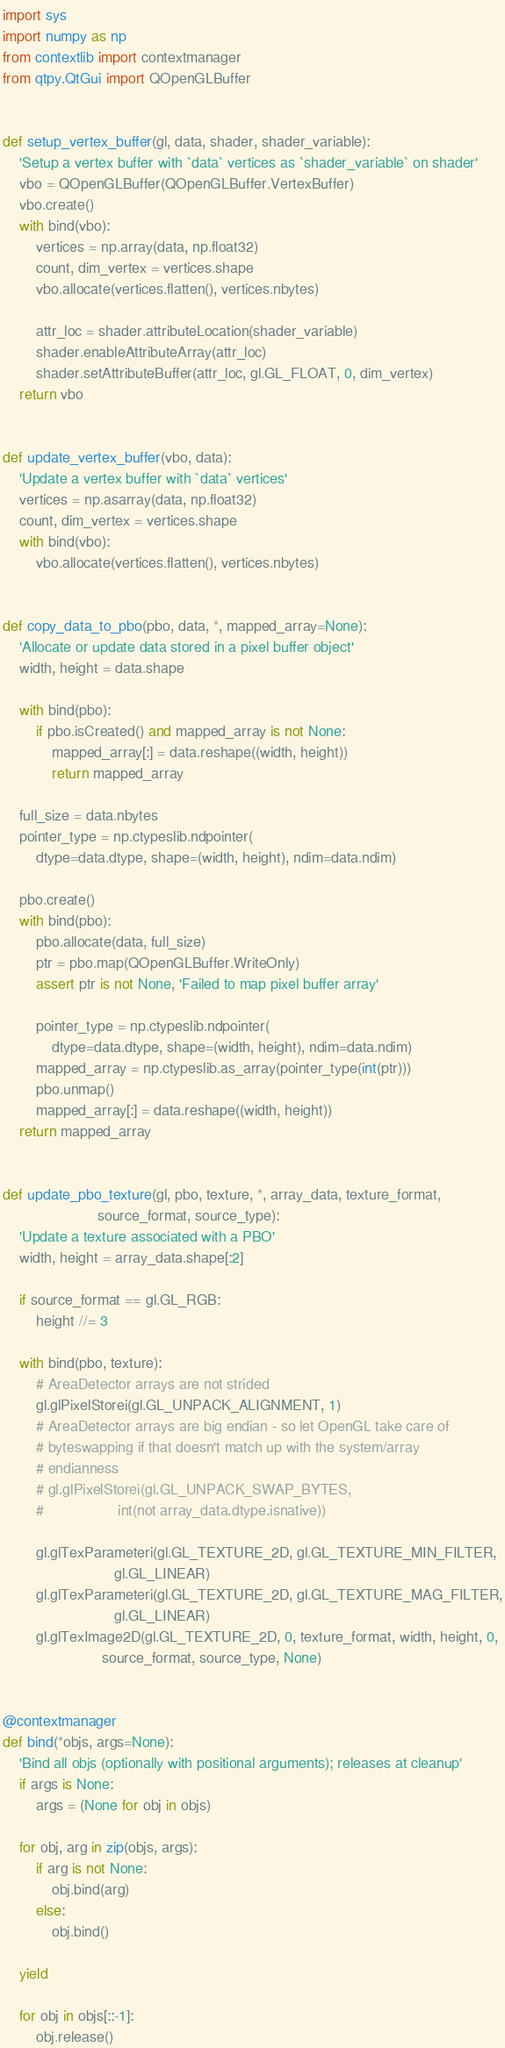<code> <loc_0><loc_0><loc_500><loc_500><_Python_>import sys
import numpy as np
from contextlib import contextmanager
from qtpy.QtGui import QOpenGLBuffer


def setup_vertex_buffer(gl, data, shader, shader_variable):
    'Setup a vertex buffer with `data` vertices as `shader_variable` on shader'
    vbo = QOpenGLBuffer(QOpenGLBuffer.VertexBuffer)
    vbo.create()
    with bind(vbo):
        vertices = np.array(data, np.float32)
        count, dim_vertex = vertices.shape
        vbo.allocate(vertices.flatten(), vertices.nbytes)

        attr_loc = shader.attributeLocation(shader_variable)
        shader.enableAttributeArray(attr_loc)
        shader.setAttributeBuffer(attr_loc, gl.GL_FLOAT, 0, dim_vertex)
    return vbo


def update_vertex_buffer(vbo, data):
    'Update a vertex buffer with `data` vertices'
    vertices = np.asarray(data, np.float32)
    count, dim_vertex = vertices.shape
    with bind(vbo):
        vbo.allocate(vertices.flatten(), vertices.nbytes)


def copy_data_to_pbo(pbo, data, *, mapped_array=None):
    'Allocate or update data stored in a pixel buffer object'
    width, height = data.shape

    with bind(pbo):
        if pbo.isCreated() and mapped_array is not None:
            mapped_array[:] = data.reshape((width, height))
            return mapped_array

    full_size = data.nbytes
    pointer_type = np.ctypeslib.ndpointer(
        dtype=data.dtype, shape=(width, height), ndim=data.ndim)

    pbo.create()
    with bind(pbo):
        pbo.allocate(data, full_size)
        ptr = pbo.map(QOpenGLBuffer.WriteOnly)
        assert ptr is not None, 'Failed to map pixel buffer array'

        pointer_type = np.ctypeslib.ndpointer(
            dtype=data.dtype, shape=(width, height), ndim=data.ndim)
        mapped_array = np.ctypeslib.as_array(pointer_type(int(ptr)))
        pbo.unmap()
        mapped_array[:] = data.reshape((width, height))
    return mapped_array


def update_pbo_texture(gl, pbo, texture, *, array_data, texture_format,
                       source_format, source_type):
    'Update a texture associated with a PBO'
    width, height = array_data.shape[:2]

    if source_format == gl.GL_RGB:
        height //= 3

    with bind(pbo, texture):
        # AreaDetector arrays are not strided
        gl.glPixelStorei(gl.GL_UNPACK_ALIGNMENT, 1)
        # AreaDetector arrays are big endian - so let OpenGL take care of
        # byteswapping if that doesn't match up with the system/array
        # endianness
        # gl.glPixelStorei(gl.GL_UNPACK_SWAP_BYTES,
        #                  int(not array_data.dtype.isnative))

        gl.glTexParameteri(gl.GL_TEXTURE_2D, gl.GL_TEXTURE_MIN_FILTER,
                           gl.GL_LINEAR)
        gl.glTexParameteri(gl.GL_TEXTURE_2D, gl.GL_TEXTURE_MAG_FILTER,
                           gl.GL_LINEAR)
        gl.glTexImage2D(gl.GL_TEXTURE_2D, 0, texture_format, width, height, 0,
                        source_format, source_type, None)


@contextmanager
def bind(*objs, args=None):
    'Bind all objs (optionally with positional arguments); releases at cleanup'
    if args is None:
        args = (None for obj in objs)

    for obj, arg in zip(objs, args):
        if arg is not None:
            obj.bind(arg)
        else:
            obj.bind()

    yield

    for obj in objs[::-1]:
        obj.release()
</code> 